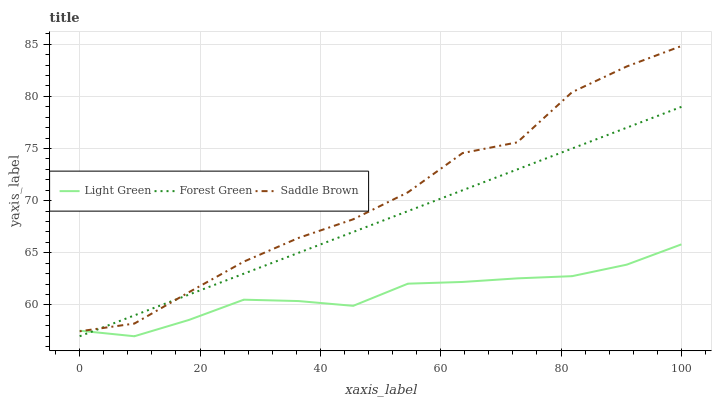Does Light Green have the minimum area under the curve?
Answer yes or no. Yes. Does Saddle Brown have the maximum area under the curve?
Answer yes or no. Yes. Does Saddle Brown have the minimum area under the curve?
Answer yes or no. No. Does Light Green have the maximum area under the curve?
Answer yes or no. No. Is Forest Green the smoothest?
Answer yes or no. Yes. Is Saddle Brown the roughest?
Answer yes or no. Yes. Is Light Green the smoothest?
Answer yes or no. No. Is Light Green the roughest?
Answer yes or no. No. Does Forest Green have the lowest value?
Answer yes or no. Yes. Does Saddle Brown have the lowest value?
Answer yes or no. No. Does Saddle Brown have the highest value?
Answer yes or no. Yes. Does Light Green have the highest value?
Answer yes or no. No. Does Forest Green intersect Light Green?
Answer yes or no. Yes. Is Forest Green less than Light Green?
Answer yes or no. No. Is Forest Green greater than Light Green?
Answer yes or no. No. 